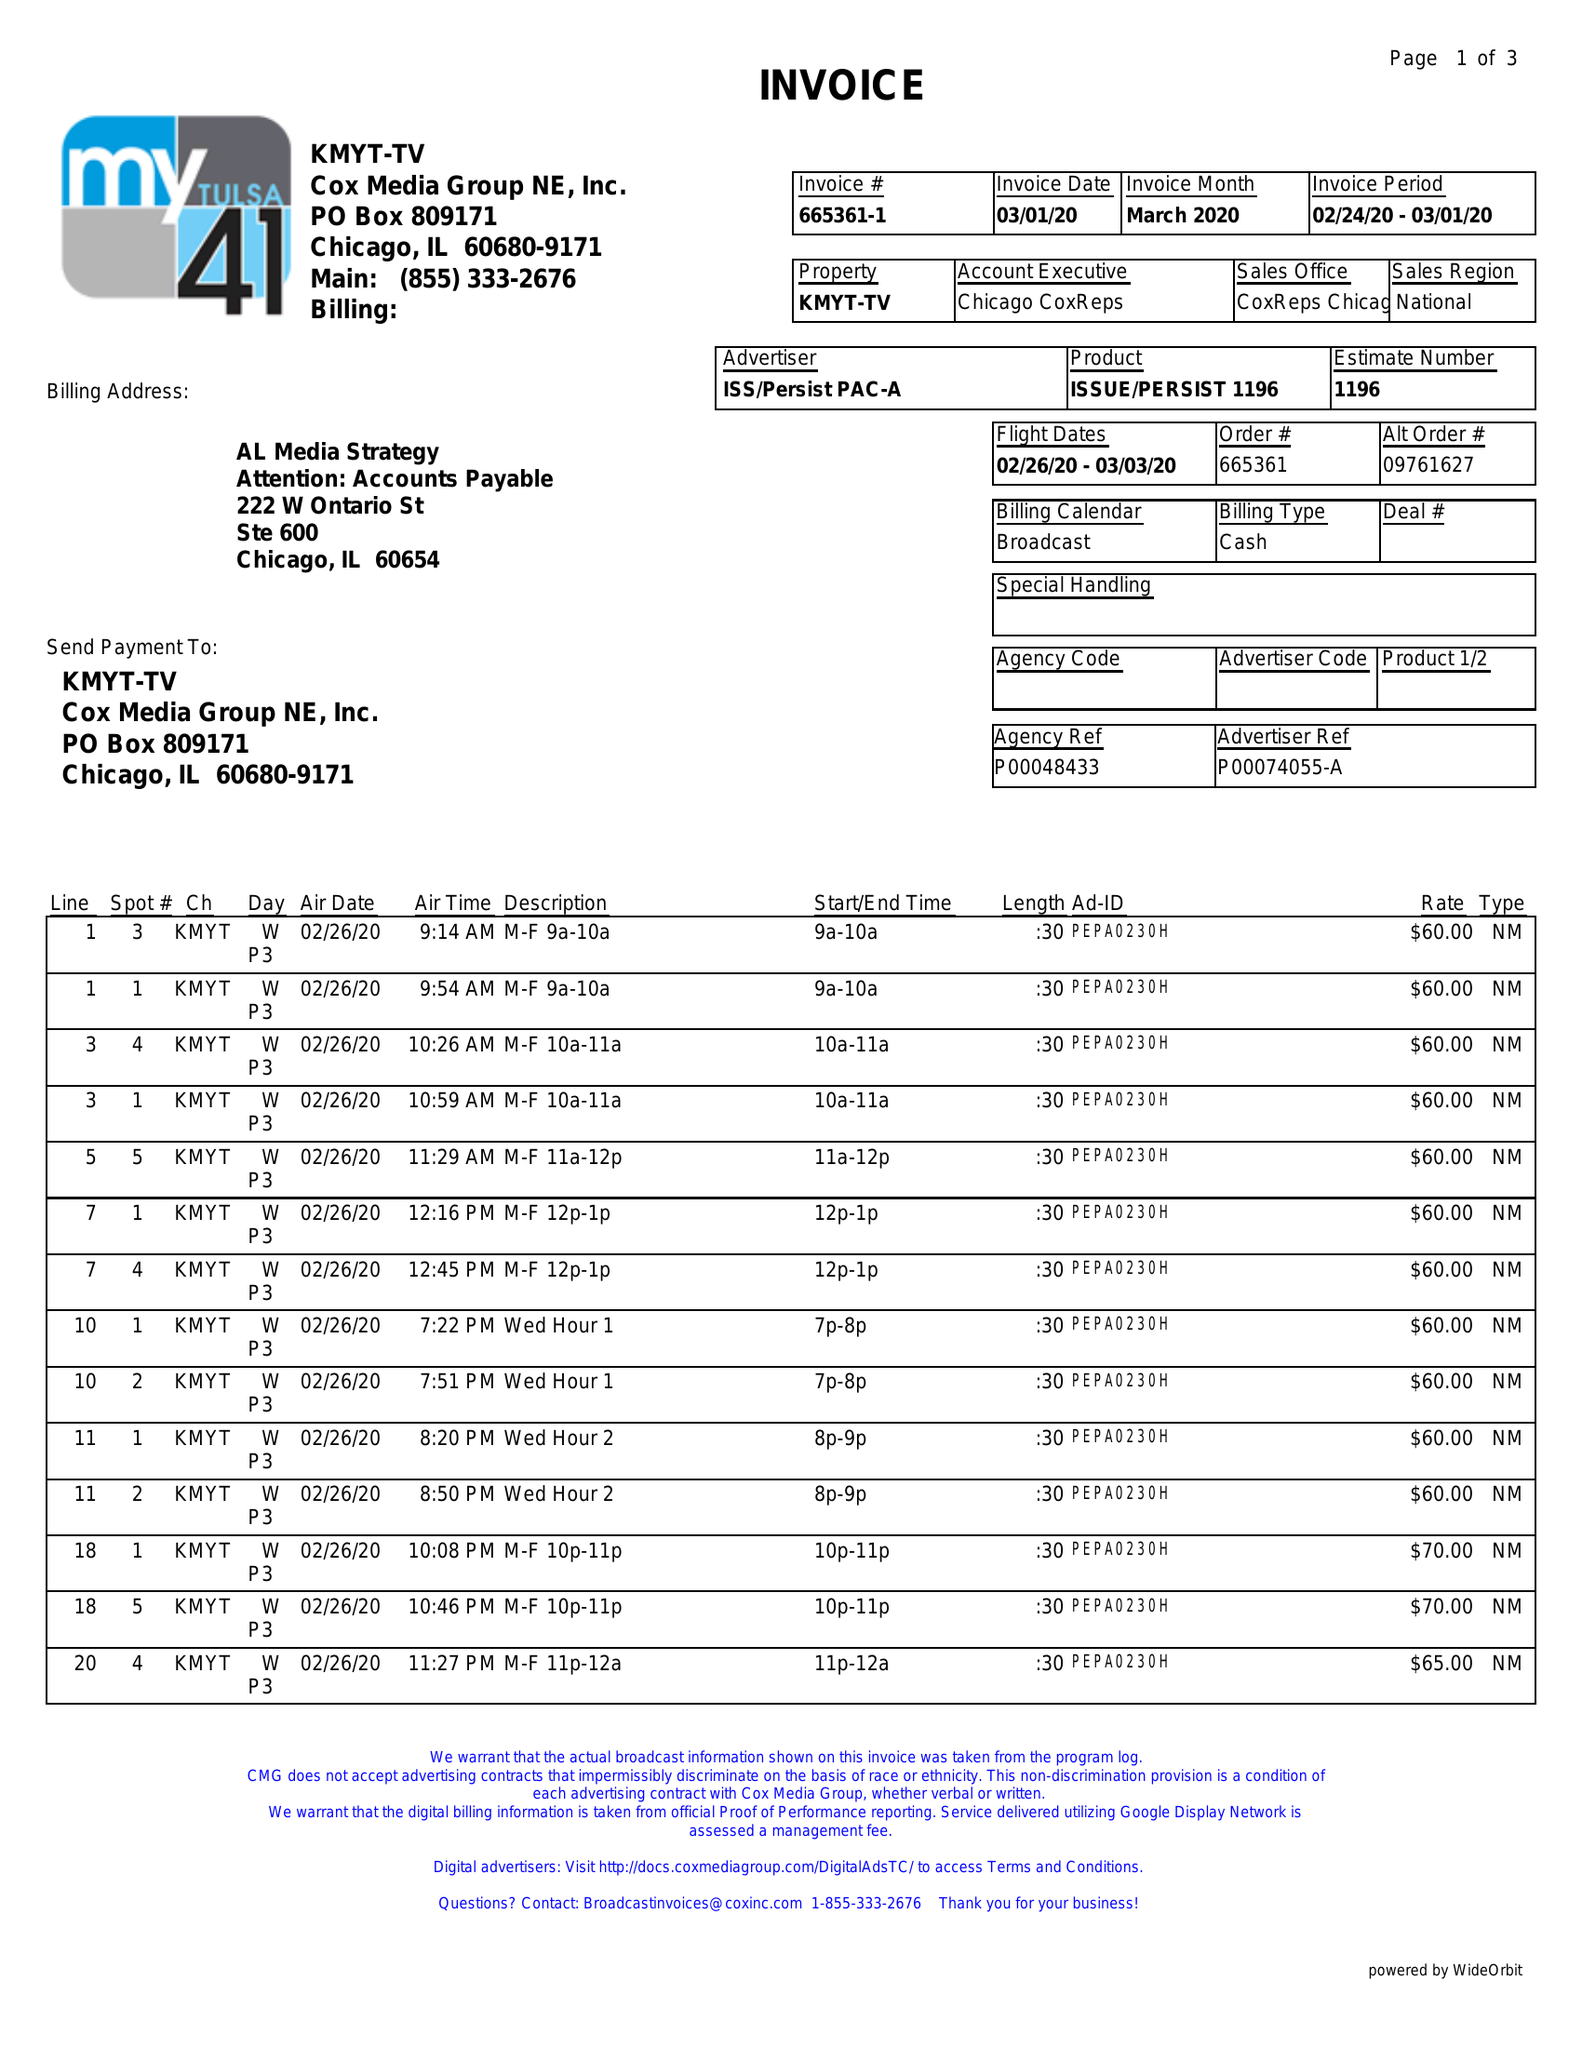What is the value for the gross_amount?
Answer the question using a single word or phrase. 3250.00 